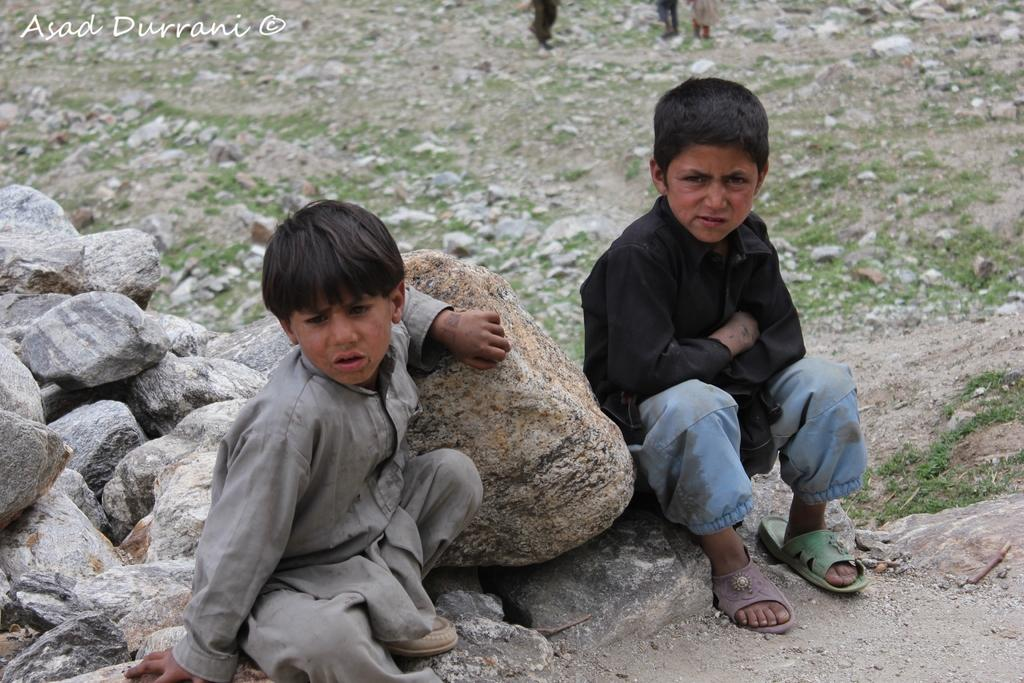How many children are in the image? There are two children in the image. What are the children doing in the image? The children are sitting on rocks. Where are the rocks located in the image? The rocks are on the left side of the image. What type of vegetation can be seen in the image? There is green grass visible in the image. What type of harmony can be heard in the image? There is no audible sound in the image, so it is not possible to determine if any harmony can be heard. 